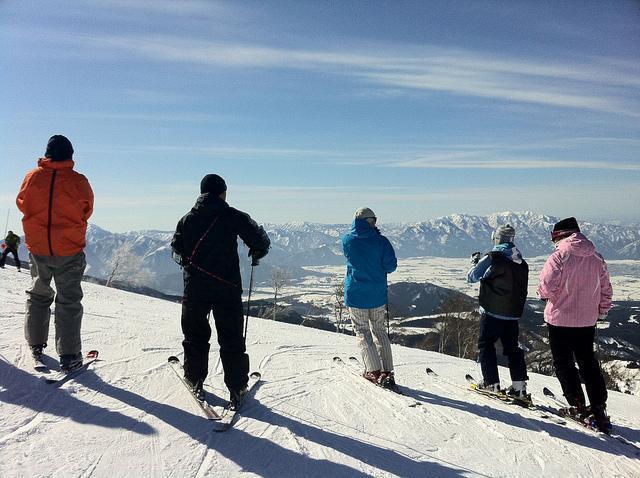How many people are standing on the hill?
Give a very brief answer. 5. How many people can be seen?
Give a very brief answer. 5. How many elephants are there?
Give a very brief answer. 0. 